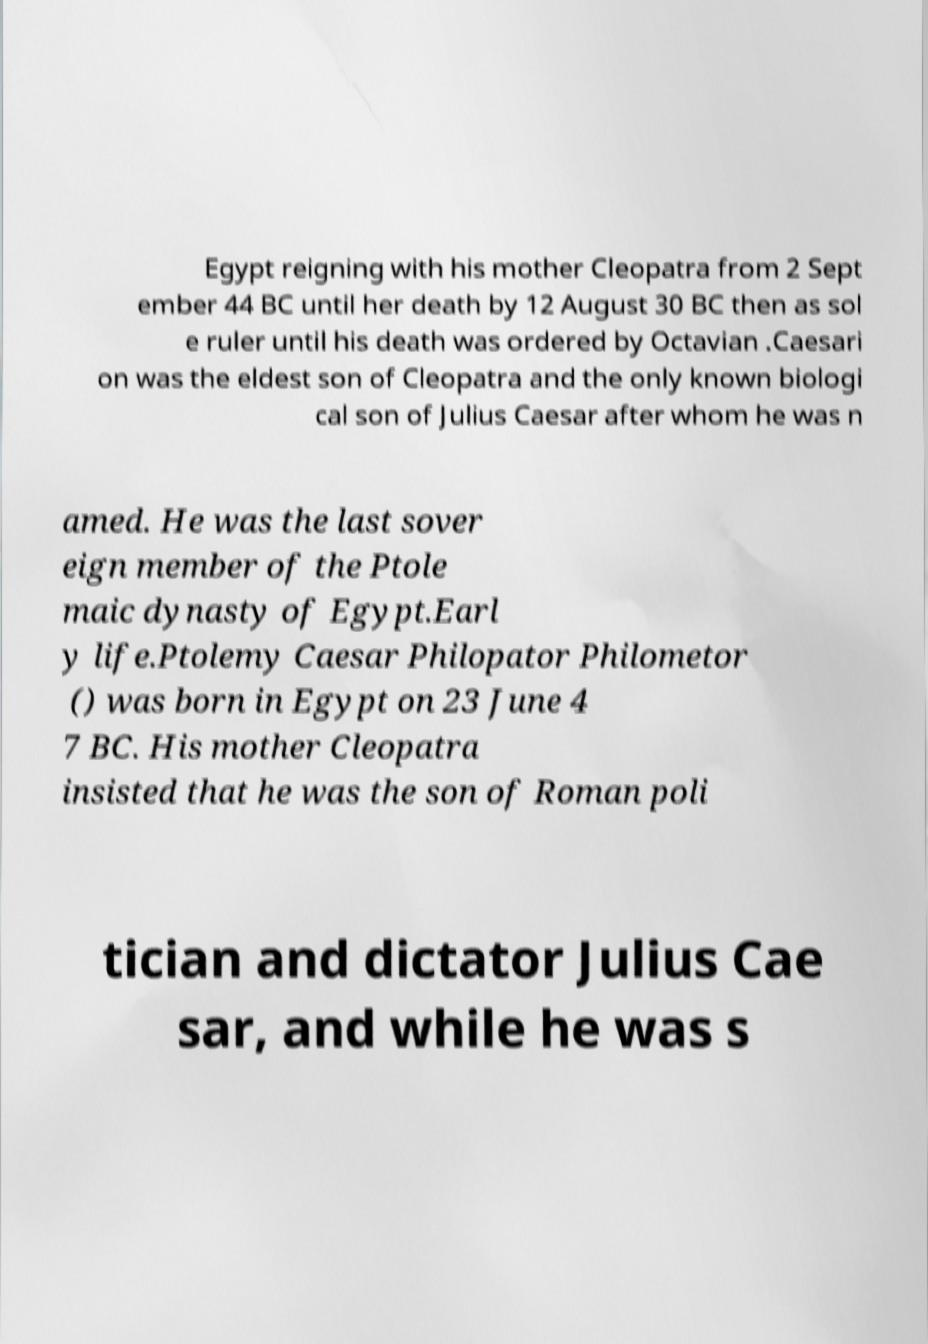Please read and relay the text visible in this image. What does it say? Egypt reigning with his mother Cleopatra from 2 Sept ember 44 BC until her death by 12 August 30 BC then as sol e ruler until his death was ordered by Octavian .Caesari on was the eldest son of Cleopatra and the only known biologi cal son of Julius Caesar after whom he was n amed. He was the last sover eign member of the Ptole maic dynasty of Egypt.Earl y life.Ptolemy Caesar Philopator Philometor () was born in Egypt on 23 June 4 7 BC. His mother Cleopatra insisted that he was the son of Roman poli tician and dictator Julius Cae sar, and while he was s 